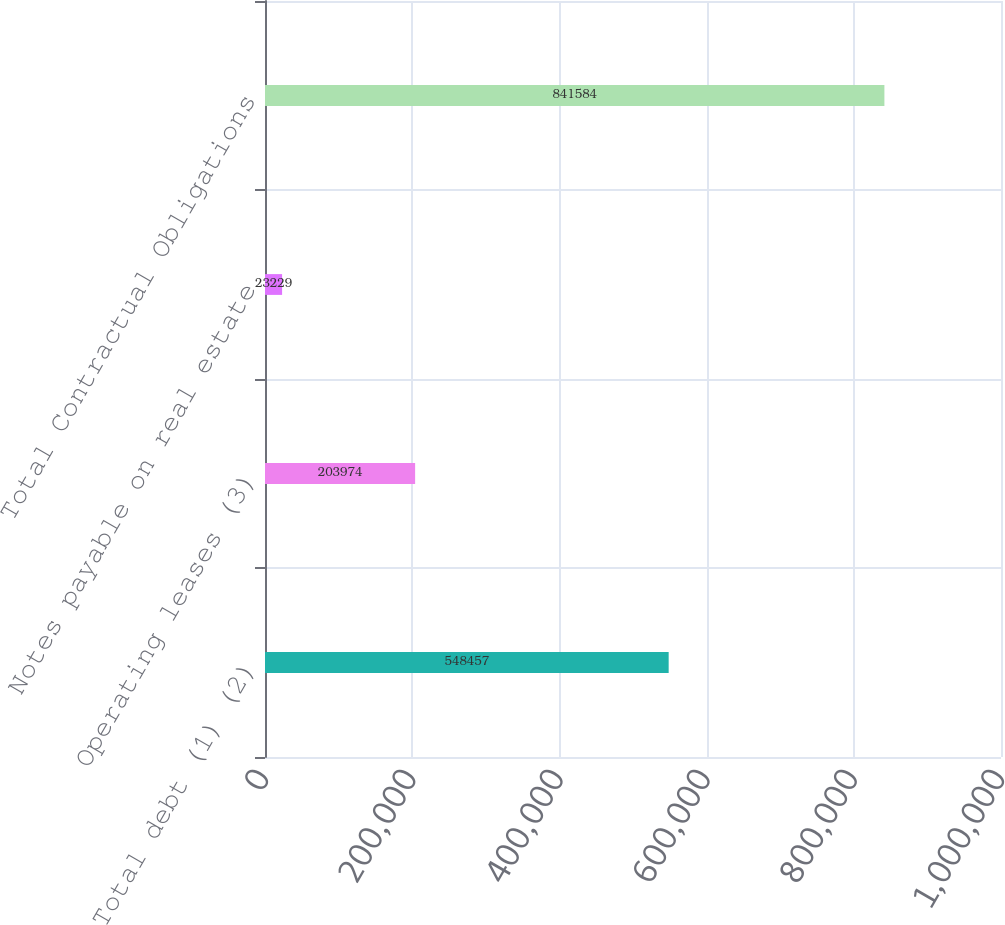<chart> <loc_0><loc_0><loc_500><loc_500><bar_chart><fcel>Total debt (1) (2)<fcel>Operating leases (3)<fcel>Notes payable on real estate<fcel>Total Contractual Obligations<nl><fcel>548457<fcel>203974<fcel>23229<fcel>841584<nl></chart> 